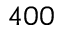Convert formula to latex. <formula><loc_0><loc_0><loc_500><loc_500>4 0 0</formula> 